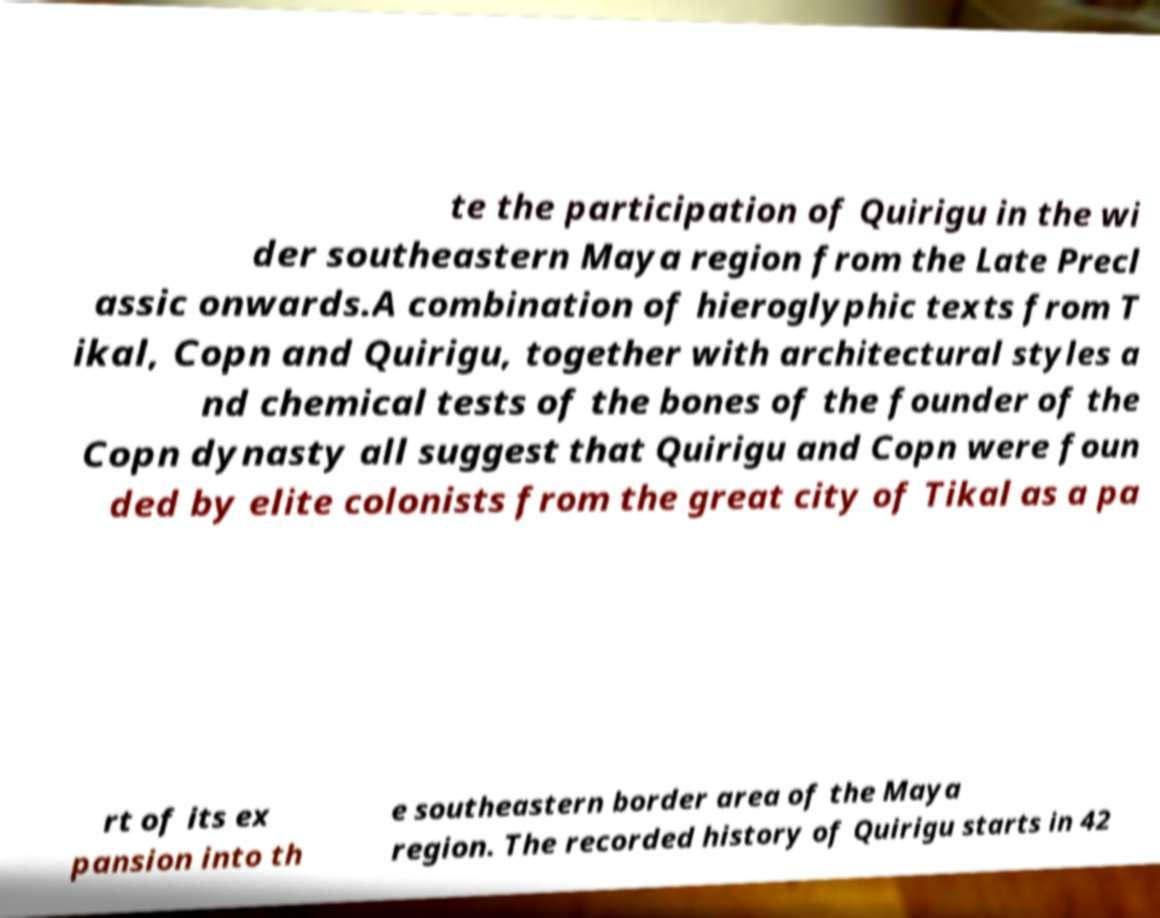Could you extract and type out the text from this image? te the participation of Quirigu in the wi der southeastern Maya region from the Late Precl assic onwards.A combination of hieroglyphic texts from T ikal, Copn and Quirigu, together with architectural styles a nd chemical tests of the bones of the founder of the Copn dynasty all suggest that Quirigu and Copn were foun ded by elite colonists from the great city of Tikal as a pa rt of its ex pansion into th e southeastern border area of the Maya region. The recorded history of Quirigu starts in 42 